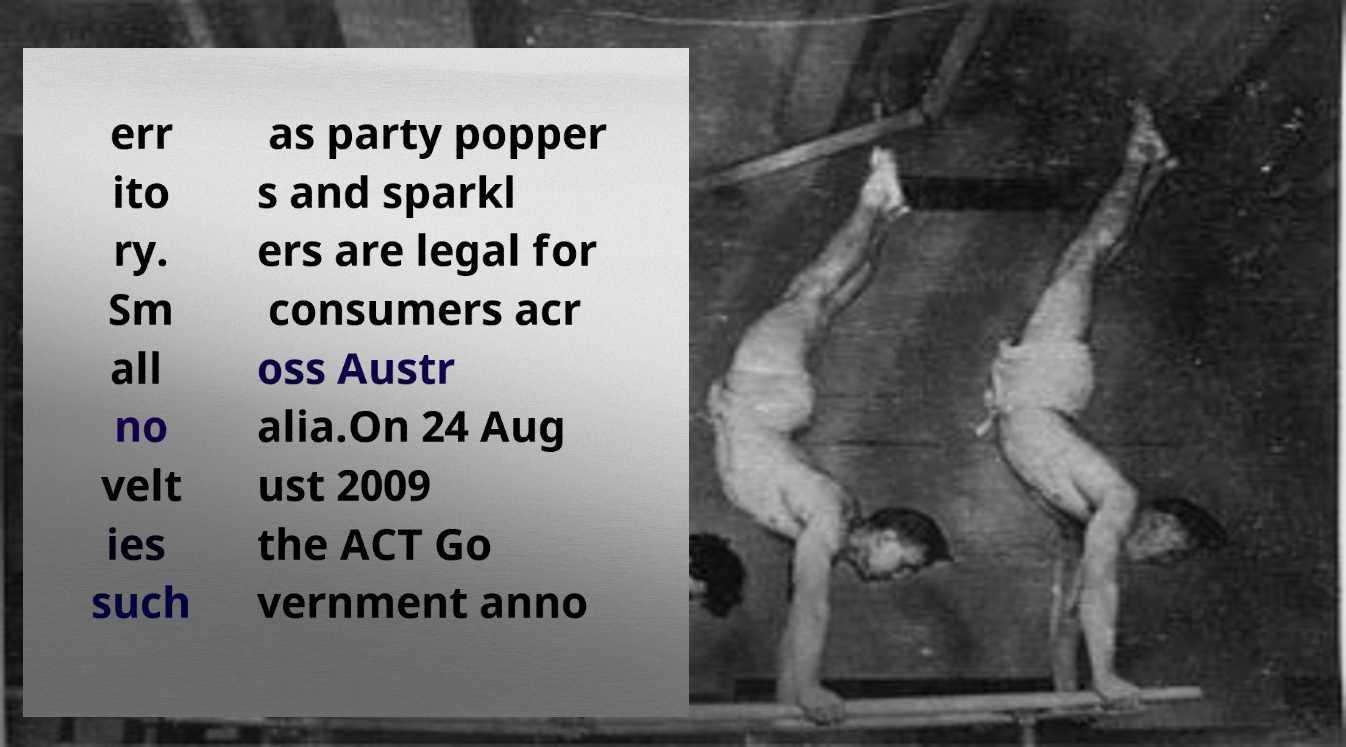Could you assist in decoding the text presented in this image and type it out clearly? err ito ry. Sm all no velt ies such as party popper s and sparkl ers are legal for consumers acr oss Austr alia.On 24 Aug ust 2009 the ACT Go vernment anno 